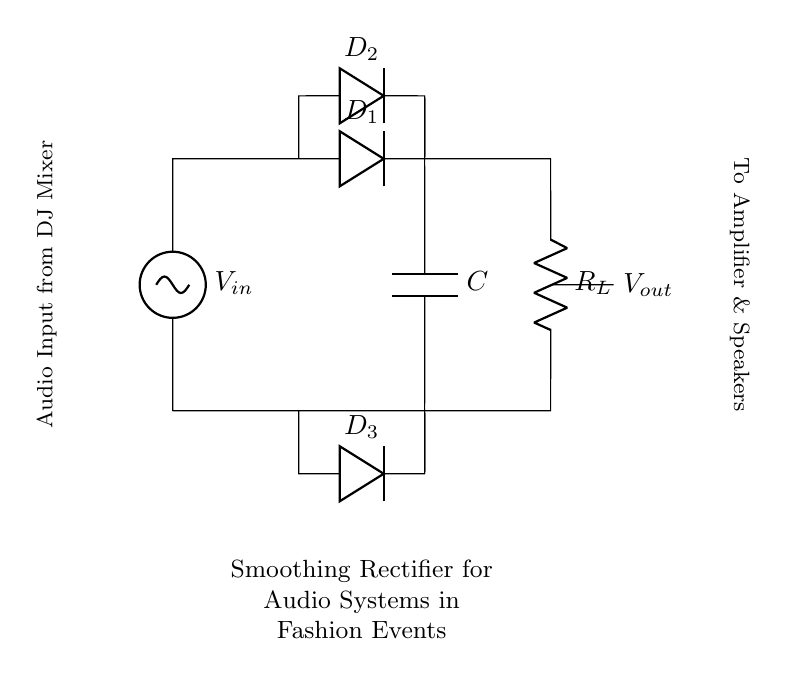What is the input voltage? The input voltage is labeled as V_in, which is the voltage supply connected at the top of the circuit.
Answer: V_in What components are in the circuit? The circuit consists of two diodes, a resistor, and a capacitor. These components are specified within the circuit diagram.
Answer: Diodes, resistor, capacitor What is the purpose of the capacitor? The capacitor acts as a smoothing component, which filters the output voltage to reduce ripple, ensuring a stable DC voltage supply to audio systems.
Answer: Smoothing How many diodes are used in the circuit? There are three diodes present in the circuit, as indicated by their labels (D_1, D_2, D_3) shown in the diagram.
Answer: Three What is the output voltage connected to? The output voltage, labeled V_out, is connected to the amplifier and speakers, which indicates the path of the processed audio signal.
Answer: Amplifier & speakers How does this circuit rectify the input AC signal? The diodes in the circuit allow current to flow in one direction only, effectively converting the AC input voltage into a pulsating DC output, which the capacitor further smooths out.
Answer: Pulsating DC 